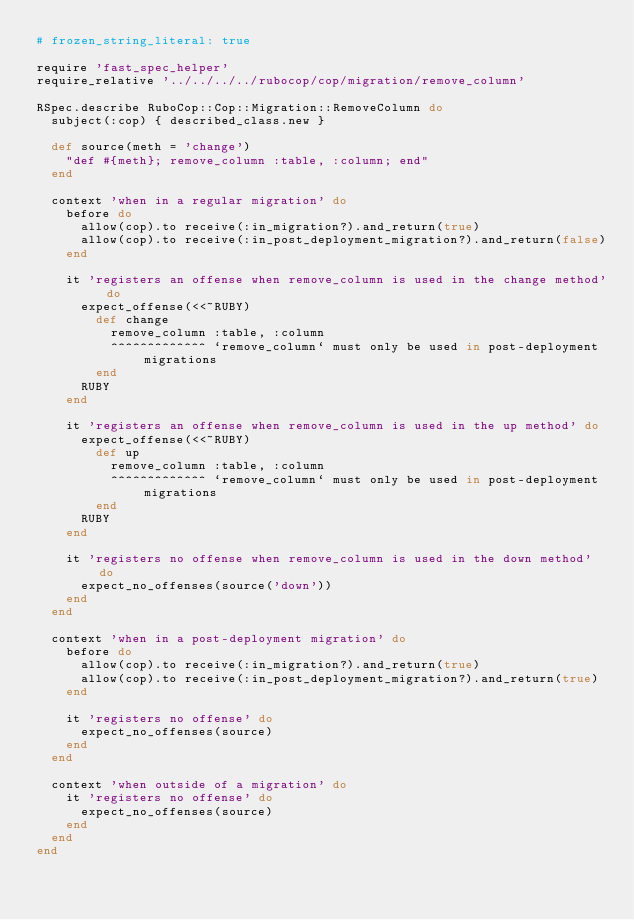<code> <loc_0><loc_0><loc_500><loc_500><_Ruby_># frozen_string_literal: true

require 'fast_spec_helper'
require_relative '../../../../rubocop/cop/migration/remove_column'

RSpec.describe RuboCop::Cop::Migration::RemoveColumn do
  subject(:cop) { described_class.new }

  def source(meth = 'change')
    "def #{meth}; remove_column :table, :column; end"
  end

  context 'when in a regular migration' do
    before do
      allow(cop).to receive(:in_migration?).and_return(true)
      allow(cop).to receive(:in_post_deployment_migration?).and_return(false)
    end

    it 'registers an offense when remove_column is used in the change method' do
      expect_offense(<<~RUBY)
        def change
          remove_column :table, :column
          ^^^^^^^^^^^^^ `remove_column` must only be used in post-deployment migrations
        end
      RUBY
    end

    it 'registers an offense when remove_column is used in the up method' do
      expect_offense(<<~RUBY)
        def up
          remove_column :table, :column
          ^^^^^^^^^^^^^ `remove_column` must only be used in post-deployment migrations
        end
      RUBY
    end

    it 'registers no offense when remove_column is used in the down method' do
      expect_no_offenses(source('down'))
    end
  end

  context 'when in a post-deployment migration' do
    before do
      allow(cop).to receive(:in_migration?).and_return(true)
      allow(cop).to receive(:in_post_deployment_migration?).and_return(true)
    end

    it 'registers no offense' do
      expect_no_offenses(source)
    end
  end

  context 'when outside of a migration' do
    it 'registers no offense' do
      expect_no_offenses(source)
    end
  end
end
</code> 